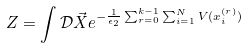Convert formula to latex. <formula><loc_0><loc_0><loc_500><loc_500>Z = \int \mathcal { D } \vec { X } e ^ { - \frac { 1 } { \epsilon _ { 2 } } \sum _ { r = 0 } ^ { k - 1 } \sum _ { i = 1 } ^ { N } V ( x _ { i } ^ { ( r ) } ) }</formula> 